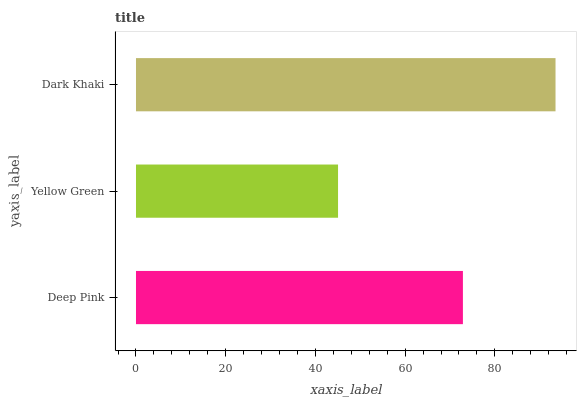Is Yellow Green the minimum?
Answer yes or no. Yes. Is Dark Khaki the maximum?
Answer yes or no. Yes. Is Dark Khaki the minimum?
Answer yes or no. No. Is Yellow Green the maximum?
Answer yes or no. No. Is Dark Khaki greater than Yellow Green?
Answer yes or no. Yes. Is Yellow Green less than Dark Khaki?
Answer yes or no. Yes. Is Yellow Green greater than Dark Khaki?
Answer yes or no. No. Is Dark Khaki less than Yellow Green?
Answer yes or no. No. Is Deep Pink the high median?
Answer yes or no. Yes. Is Deep Pink the low median?
Answer yes or no. Yes. Is Yellow Green the high median?
Answer yes or no. No. Is Yellow Green the low median?
Answer yes or no. No. 